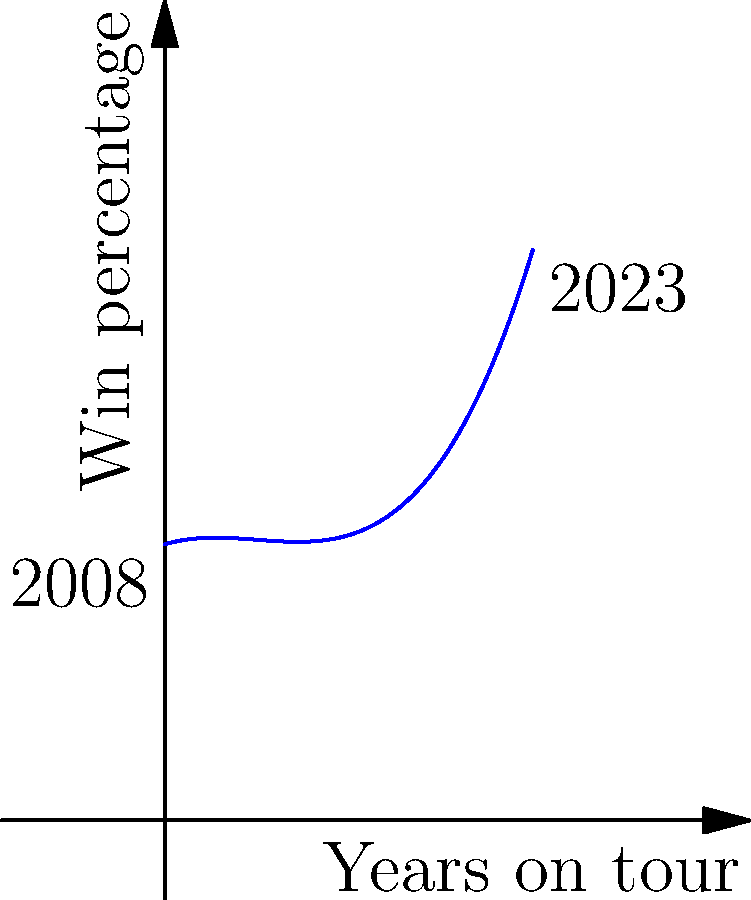The graph above represents Novak Djokovic's win percentage over his professional career from 2008 to 2023. The curve is modeled by the function $f(x) = 0.0002x^3 - 0.015x^2 + 0.3x + 75$, where $x$ represents the number of years since 2008, and $f(x)$ is the win percentage. Calculate the area under this curve from 2008 to 2023, which represents Djokovic's cumulative win percentage over his career. Round your answer to the nearest whole number. To find the area under the curve, we need to integrate the function $f(x)$ from $x=0$ (2008) to $x=15$ (2023):

1) The integral is:
   $$\int_0^{15} (0.0002x^3 - 0.015x^2 + 0.3x + 75) dx$$

2) Integrate each term:
   $$\left[ 0.00005x^4 - 0.005x^3 + 0.15x^2 + 75x \right]_0^{15}$$

3) Evaluate at the upper and lower bounds:
   $$(0.00005(15^4) - 0.005(15^3) + 0.15(15^2) + 75(15)) - (0.00005(0^4) - 0.005(0^3) + 0.15(0^2) + 75(0))$$

4) Simplify:
   $$(42.1875 - 16.875 + 33.75 + 1125) - 0 = 1184.0625$$

5) Round to the nearest whole number: 1184

This represents the cumulative win percentage over Djokovic's career from 2008 to 2023.
Answer: 1184 